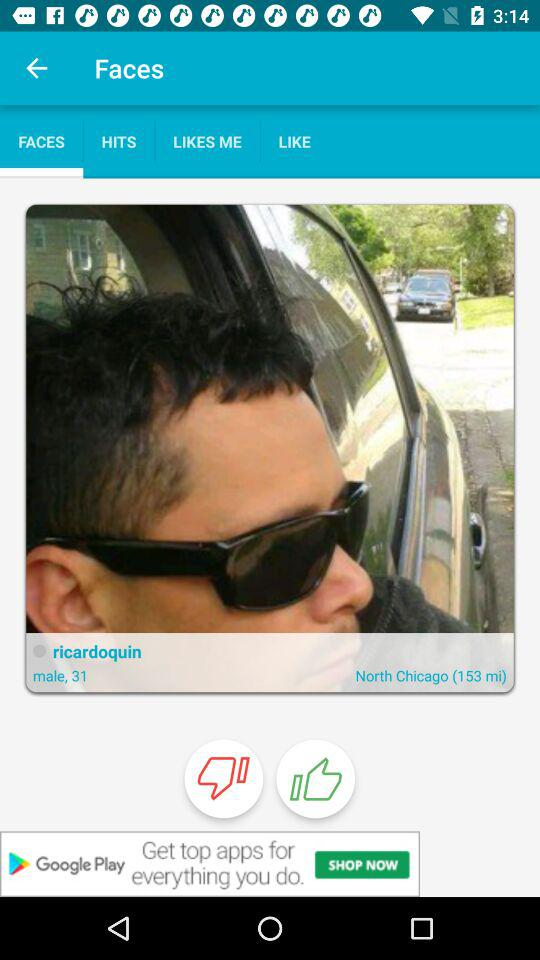What is the profile name? The profile name is Ricardoquin. 